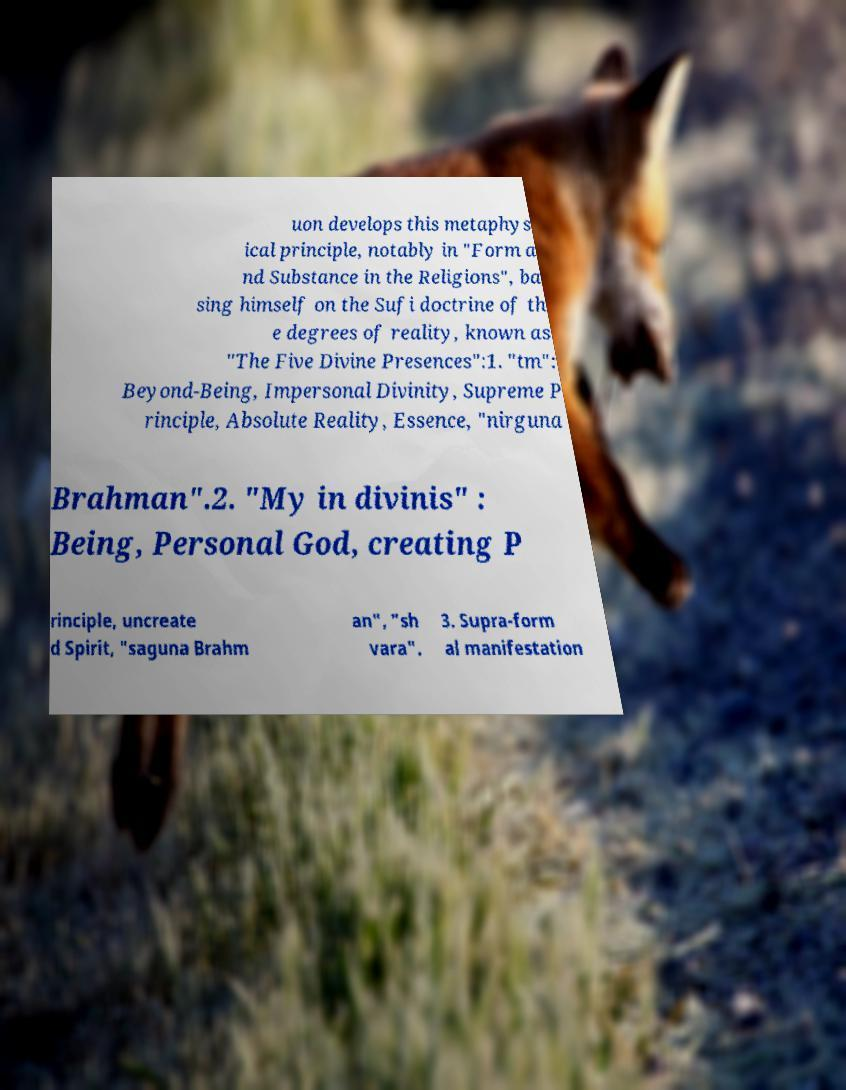Can you accurately transcribe the text from the provided image for me? uon develops this metaphys ical principle, notably in "Form a nd Substance in the Religions", ba sing himself on the Sufi doctrine of th e degrees of reality, known as "The Five Divine Presences":1. "tm": Beyond-Being, Impersonal Divinity, Supreme P rinciple, Absolute Reality, Essence, "nirguna Brahman".2. "My in divinis" : Being, Personal God, creating P rinciple, uncreate d Spirit, "saguna Brahm an", "sh vara". 3. Supra-form al manifestation 